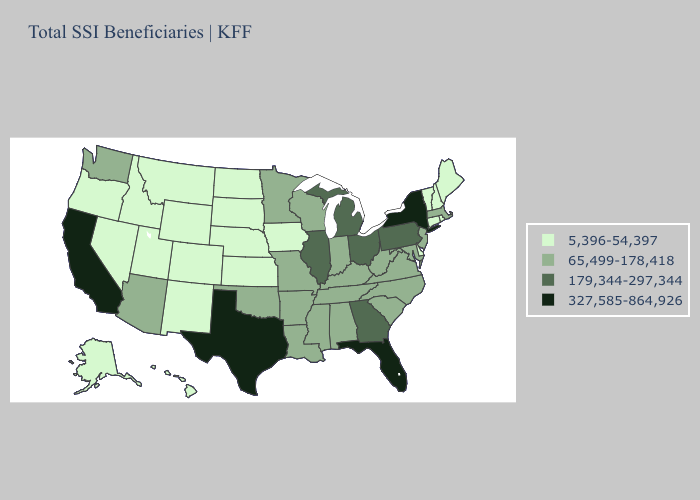Name the states that have a value in the range 179,344-297,344?
Quick response, please. Georgia, Illinois, Michigan, Ohio, Pennsylvania. Does New York have the highest value in the Northeast?
Concise answer only. Yes. Does South Carolina have a higher value than Texas?
Short answer required. No. What is the value of Kansas?
Quick response, please. 5,396-54,397. Does Arizona have the lowest value in the West?
Concise answer only. No. Name the states that have a value in the range 179,344-297,344?
Short answer required. Georgia, Illinois, Michigan, Ohio, Pennsylvania. Among the states that border New York , which have the lowest value?
Quick response, please. Connecticut, Vermont. Name the states that have a value in the range 327,585-864,926?
Write a very short answer. California, Florida, New York, Texas. Which states have the highest value in the USA?
Write a very short answer. California, Florida, New York, Texas. Which states have the lowest value in the USA?
Quick response, please. Alaska, Colorado, Connecticut, Delaware, Hawaii, Idaho, Iowa, Kansas, Maine, Montana, Nebraska, Nevada, New Hampshire, New Mexico, North Dakota, Oregon, Rhode Island, South Dakota, Utah, Vermont, Wyoming. What is the lowest value in the West?
Keep it brief. 5,396-54,397. What is the value of Pennsylvania?
Concise answer only. 179,344-297,344. Name the states that have a value in the range 65,499-178,418?
Concise answer only. Alabama, Arizona, Arkansas, Indiana, Kentucky, Louisiana, Maryland, Massachusetts, Minnesota, Mississippi, Missouri, New Jersey, North Carolina, Oklahoma, South Carolina, Tennessee, Virginia, Washington, West Virginia, Wisconsin. How many symbols are there in the legend?
Write a very short answer. 4. Does North Dakota have the lowest value in the USA?
Short answer required. Yes. 